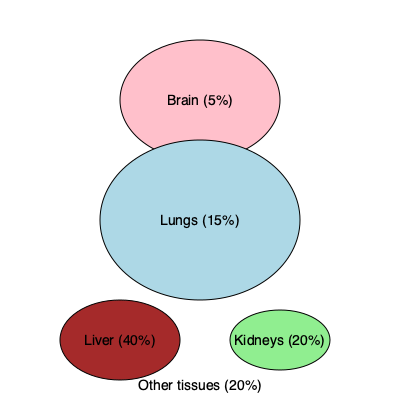Based on the simplified body diagram showing nanoparticle biodistribution, calculate the ratio of nanoparticle accumulation in the liver compared to the lungs. How might this information influence the design of nanoparticles for cancer treatment in these organs? To solve this problem, we need to follow these steps:

1. Identify the percentage of nanoparticle accumulation in the liver and lungs:
   - Liver: 40%
   - Lungs: 15%

2. Calculate the ratio of liver accumulation to lung accumulation:
   $\text{Ratio} = \frac{\text{Liver accumulation}}{\text{Lung accumulation}} = \frac{40\%}{15\%} = \frac{40}{15} = \frac{8}{3} \approx 2.67$

3. Interpret the result:
   The liver accumulates about 2.67 times more nanoparticles than the lungs.

4. Consider the implications for nanoparticle design in cancer treatment:
   a) For liver cancer: The high accumulation in the liver (40%) suggests that nanoparticles could be effective for liver cancer treatment, as they naturally target this organ. However, this may also increase the risk of hepatotoxicity, so the nanoparticles should be designed to minimize damage to healthy liver tissue.

   b) For lung cancer: The lower accumulation in the lungs (15%) indicates that nanoparticles may need to be specifically engineered to increase their targeting to lung tissue. This could involve:
      - Modifying the surface of nanoparticles with lung-specific targeting ligands
      - Adjusting the size and shape of nanoparticles to enhance retention in lung capillaries
      - Considering alternative administration routes, such as inhalation, to increase local concentration in the lungs

   c) General considerations: The high accumulation in the liver suggests that nanoparticles may be rapidly cleared from the bloodstream. To improve circulation time and increase the chance of reaching target tissues, strategies such as PEGylation or using stealth coatings could be employed.
Answer: Liver-to-lung accumulation ratio: 2.67. Design implications: enhance lung targeting for lung cancer; leverage natural liver accumulation for liver cancer while managing toxicity; improve circulation time for other targets. 